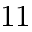Convert formula to latex. <formula><loc_0><loc_0><loc_500><loc_500>1 1</formula> 